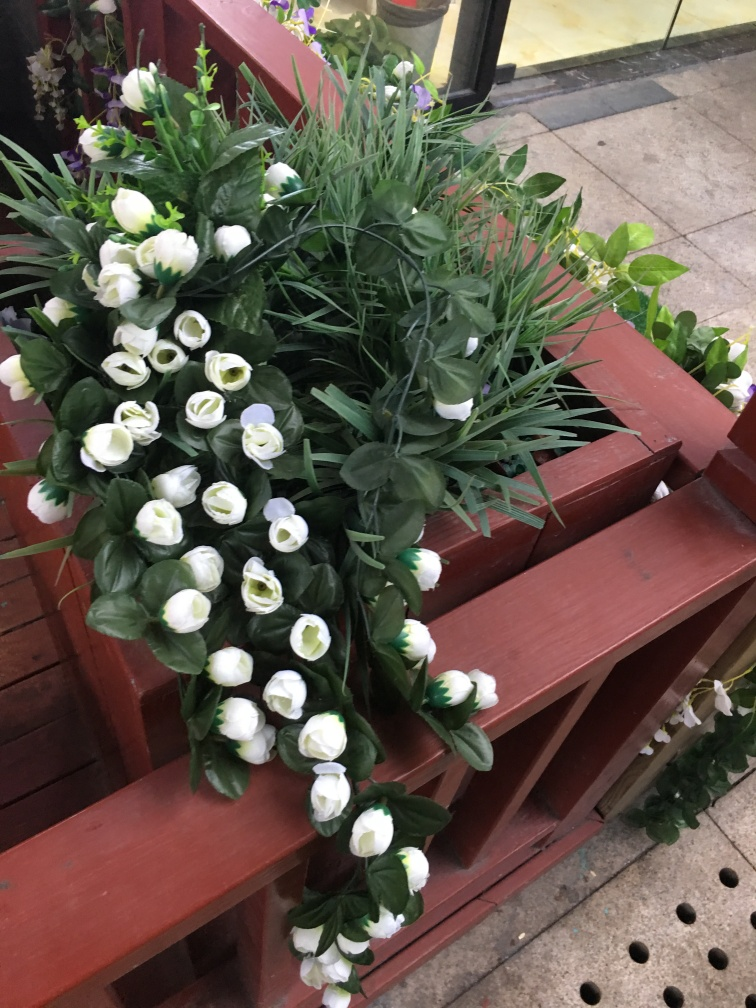What is the main subject of the image?
A. A person
B. An animal
C. A plant
Answer with the option's letter from the given choices directly. The main subject of the image is a lovely collection of plants, specifically artificial flowers arranged beautifully on a wooden set of shelves. The image shows an assortment of white artificial flowers, possibly tulips, with green foliage, creating a vibrant display that captures the essence of a blooming garden inside what appears to be a florist's shop or a decorative setting. 